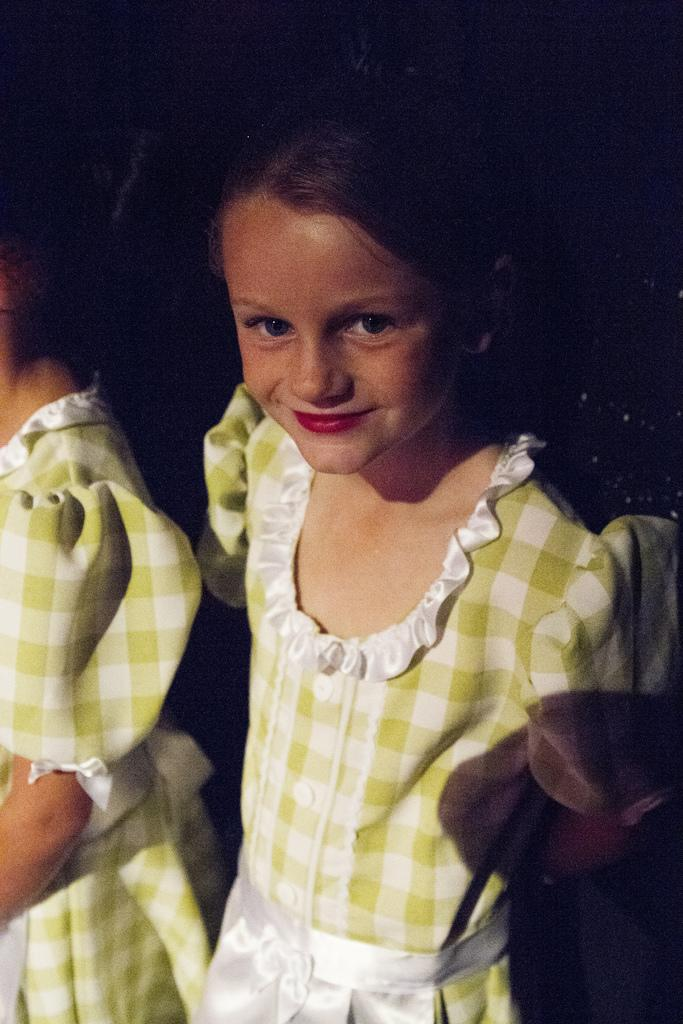What is the main subject of the image? The main subject of the image is a girl standing. Can you describe the girl's attire? The girl is wearing a frock. Are there any other people in the image? Yes, there is another girl standing beside her in the image. What type of pet is the girl holding in the image? There is no pet visible in the image. What advice does the girl give to the other girl in the image? The image does not depict any interaction between the two girls, so it is impossible to determine if advice is being given. 